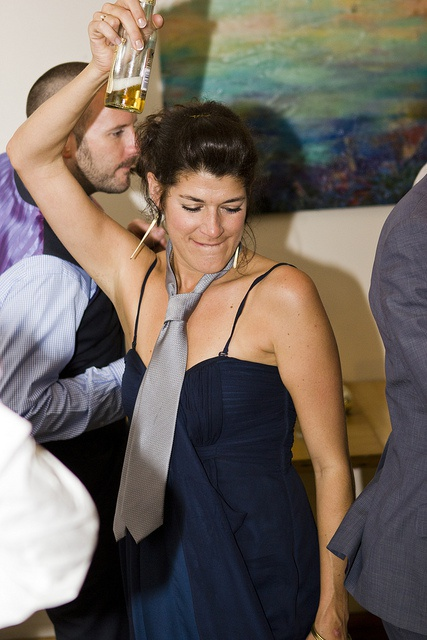Describe the objects in this image and their specific colors. I can see people in lightgray, black, tan, and gray tones, people in lightgray, gray, darkgray, and black tones, people in lightgray, gray, and black tones, tie in lightgray, darkgray, and gray tones, and people in lightgray, tan, gray, and maroon tones in this image. 